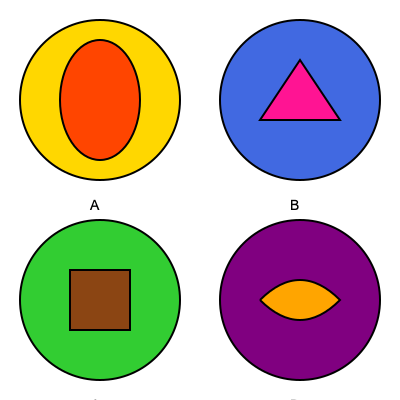As an artifact collector specializing in historic bowling equipment, you're examining a set of bowling balls with different core shapes. Which core shape is most commonly associated with a symmetrical ball designed for a smoother, more predictable roll on the lane? To answer this question, let's analyze each core shape presented in the image:

1. Ball A: This core has an elliptical shape within a circular ball. This is known as an asymmetrical core, which typically creates more hook potential and is less predictable.

2. Ball B: The core here is triangular. This is another asymmetrical design, often used in high-performance balls for experienced bowlers who want to create a specific motion on the lane.

3. Ball C: This ball has a rectangular core. While not as common, this is also an asymmetrical design that can create a strong backend reaction.

4. Ball D: The core in this ball is a rounded pancake shape. This is a symmetrical core design, which is known for providing a smoother, more predictable roll.

Symmetrical cores, like the one in Ball D, are designed to maintain their orientation as the ball rolls down the lane. This results in a more consistent and controllable ball motion, which is ideal for bowlers looking for reliability and precision in their shots.

In contrast, asymmetrical cores (like those in Balls A, B, and C) are designed to create more dynamic motion, often resulting in a stronger hook potential but less predictability.

Therefore, among the options presented, the core shape most commonly associated with a symmetrical ball designed for a smoother, more predictable roll is the one shown in Ball D.
Answer: Ball D (rounded pancake core) 